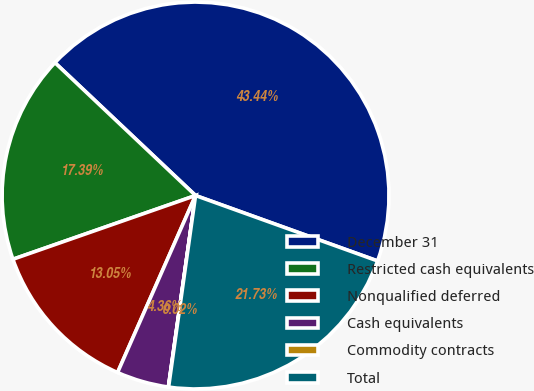Convert chart. <chart><loc_0><loc_0><loc_500><loc_500><pie_chart><fcel>December 31<fcel>Restricted cash equivalents<fcel>Nonqualified deferred<fcel>Cash equivalents<fcel>Commodity contracts<fcel>Total<nl><fcel>43.44%<fcel>17.39%<fcel>13.05%<fcel>4.36%<fcel>0.02%<fcel>21.73%<nl></chart> 